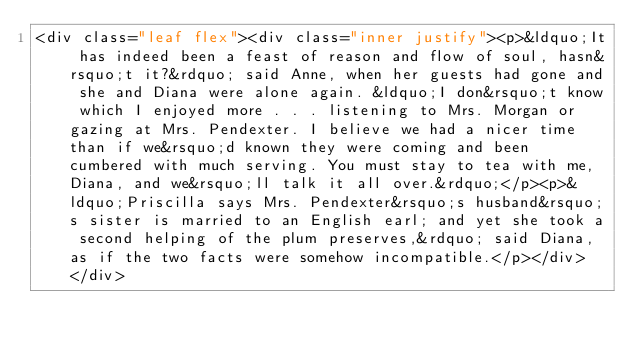<code> <loc_0><loc_0><loc_500><loc_500><_HTML_><div class="leaf flex"><div class="inner justify"><p>&ldquo;It has indeed been a feast of reason and flow of soul, hasn&rsquo;t it?&rdquo; said Anne, when her guests had gone and she and Diana were alone again. &ldquo;I don&rsquo;t know which I enjoyed more . . . listening to Mrs. Morgan or gazing at Mrs. Pendexter. I believe we had a nicer time than if we&rsquo;d known they were coming and been cumbered with much serving. You must stay to tea with me, Diana, and we&rsquo;ll talk it all over.&rdquo;</p><p>&ldquo;Priscilla says Mrs. Pendexter&rsquo;s husband&rsquo;s sister is married to an English earl; and yet she took a second helping of the plum preserves,&rdquo; said Diana, as if the two facts were somehow incompatible.</p></div> </div></code> 